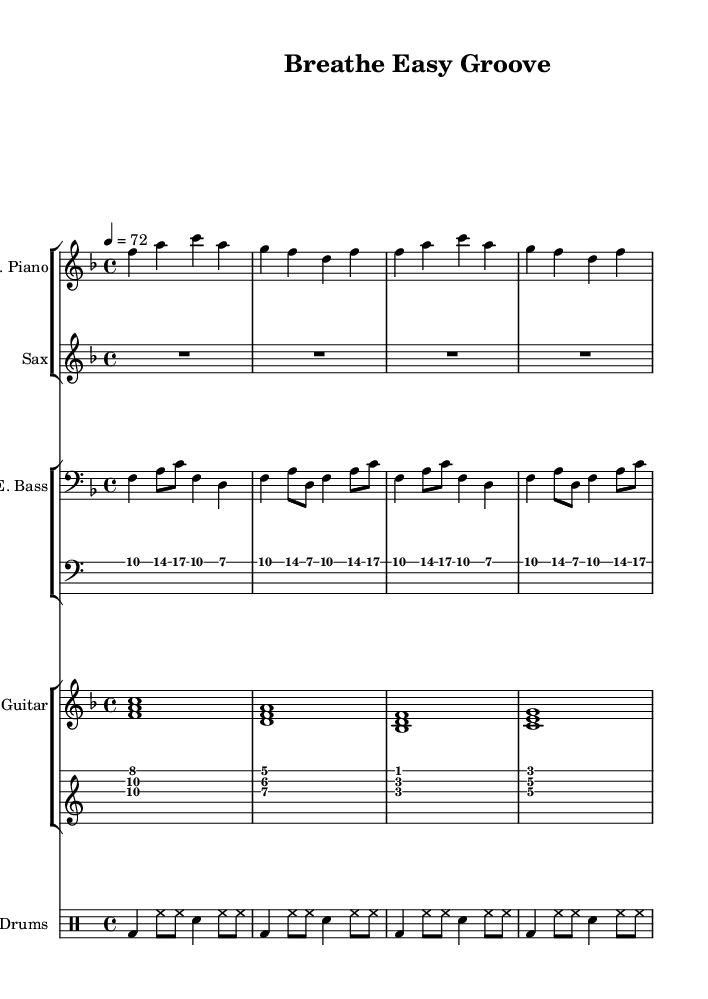What is the key signature of this music? The key signature is F major, which has one flat (B flat). This can be identified by looking at the key signature noted at the beginning of the staff.
Answer: F major What is the time signature of this piece? The time signature is 4/4, indicating that there are four beats per measure and a quarter note gets one beat. This is shown at the beginning of the score.
Answer: 4/4 What is the tempo marking for the piece? The tempo marking is 72 BPM, indicating the beats per minute at which the piece should be played. This is specified in the tempo instruction at the start: "4 = 72".
Answer: 72 BPM How many measures does the electric piano part contain? The electric piano part contains four measures, which can be found by counting the vertical bar lines that indicate the end of each measure in the staff.
Answer: Four measures What type of groove is represented in the drum patterns? The groove represented in the drum patterns is a laid-back, syncopated funk groove, distinguished by bass drum and snare placements that create a relaxed rhythmic feel. This can be inferred from the specific rhythmic patterns typical of funk drumming.
Answer: Funk groove What is the rhythmic texture of the bass line? The rhythmic texture of the bass line consists of steady quarter notes and syncopated eighth notes, contributing to the overall relaxed feel of the funk genre while allowing for rhythmic variation. This observation is derived from the combination of note types in the bass staff.
Answer: Steady and syncopated What is the instrumental role of the saxophone in this piece? The saxophone part is designated as a rest throughout the score, indicating that it does not play any notes in this composition. This is noted by the "R1*4" which shows a whole measure rest.
Answer: Rest 